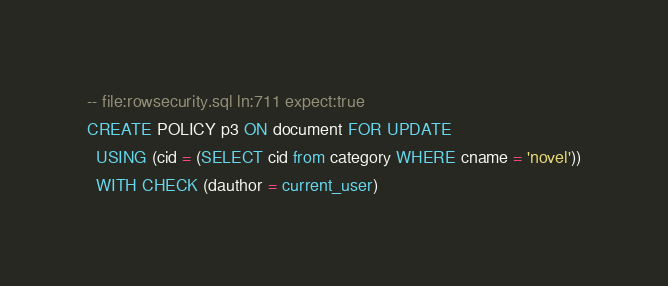Convert code to text. <code><loc_0><loc_0><loc_500><loc_500><_SQL_>-- file:rowsecurity.sql ln:711 expect:true
CREATE POLICY p3 ON document FOR UPDATE
  USING (cid = (SELECT cid from category WHERE cname = 'novel'))
  WITH CHECK (dauthor = current_user)
</code> 